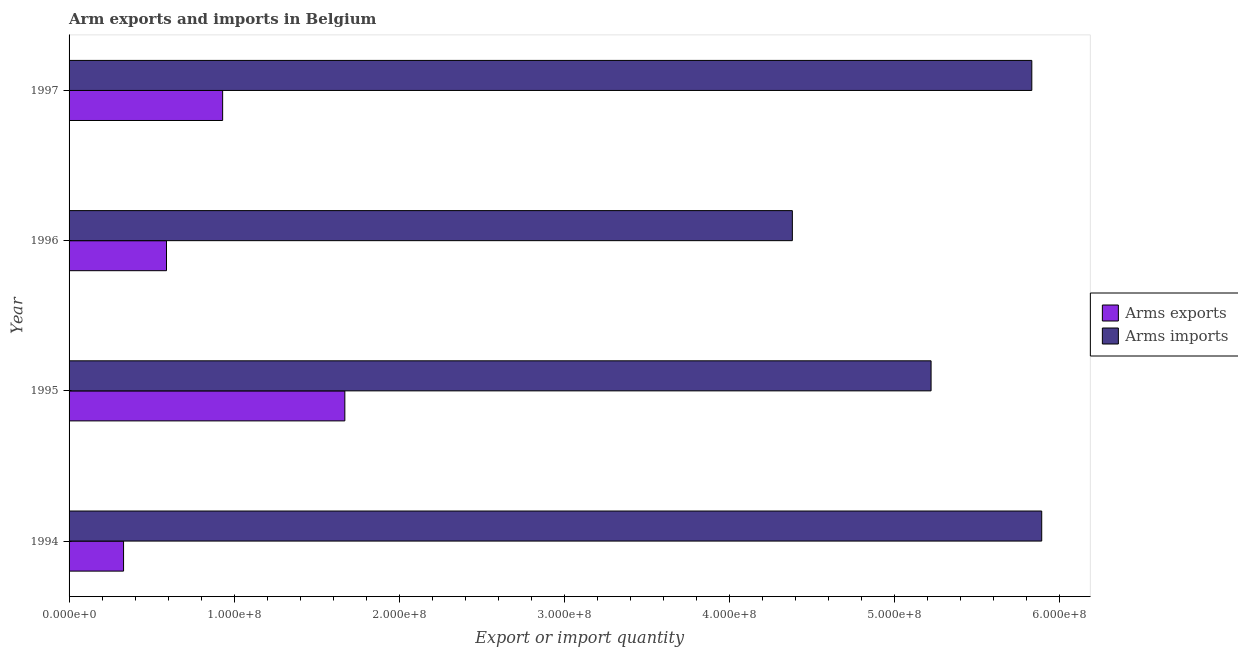How many different coloured bars are there?
Offer a very short reply. 2. How many bars are there on the 2nd tick from the top?
Make the answer very short. 2. How many bars are there on the 4th tick from the bottom?
Make the answer very short. 2. What is the arms imports in 1995?
Offer a terse response. 5.22e+08. Across all years, what is the maximum arms exports?
Offer a terse response. 1.67e+08. Across all years, what is the minimum arms exports?
Offer a very short reply. 3.30e+07. In which year was the arms imports maximum?
Give a very brief answer. 1994. What is the total arms imports in the graph?
Your response must be concise. 2.13e+09. What is the difference between the arms exports in 1996 and that in 1997?
Offer a very short reply. -3.40e+07. What is the difference between the arms imports in 1994 and the arms exports in 1996?
Give a very brief answer. 5.30e+08. What is the average arms imports per year?
Give a very brief answer. 5.33e+08. In the year 1996, what is the difference between the arms exports and arms imports?
Your answer should be very brief. -3.79e+08. In how many years, is the arms exports greater than 400000000 ?
Your response must be concise. 0. What is the ratio of the arms imports in 1995 to that in 1997?
Keep it short and to the point. 0.9. Is the arms exports in 1996 less than that in 1997?
Make the answer very short. Yes. What is the difference between the highest and the second highest arms exports?
Keep it short and to the point. 7.40e+07. What is the difference between the highest and the lowest arms exports?
Provide a short and direct response. 1.34e+08. Is the sum of the arms exports in 1994 and 1997 greater than the maximum arms imports across all years?
Offer a very short reply. No. What does the 1st bar from the top in 1996 represents?
Provide a succinct answer. Arms imports. What does the 2nd bar from the bottom in 1997 represents?
Keep it short and to the point. Arms imports. How many bars are there?
Ensure brevity in your answer.  8. How many years are there in the graph?
Your response must be concise. 4. Are the values on the major ticks of X-axis written in scientific E-notation?
Your response must be concise. Yes. Does the graph contain any zero values?
Your answer should be very brief. No. How are the legend labels stacked?
Your answer should be very brief. Vertical. What is the title of the graph?
Your response must be concise. Arm exports and imports in Belgium. Does "Mobile cellular" appear as one of the legend labels in the graph?
Your answer should be very brief. No. What is the label or title of the X-axis?
Give a very brief answer. Export or import quantity. What is the label or title of the Y-axis?
Keep it short and to the point. Year. What is the Export or import quantity of Arms exports in 1994?
Provide a succinct answer. 3.30e+07. What is the Export or import quantity of Arms imports in 1994?
Provide a short and direct response. 5.89e+08. What is the Export or import quantity of Arms exports in 1995?
Ensure brevity in your answer.  1.67e+08. What is the Export or import quantity in Arms imports in 1995?
Provide a short and direct response. 5.22e+08. What is the Export or import quantity in Arms exports in 1996?
Your answer should be compact. 5.90e+07. What is the Export or import quantity in Arms imports in 1996?
Provide a short and direct response. 4.38e+08. What is the Export or import quantity in Arms exports in 1997?
Keep it short and to the point. 9.30e+07. What is the Export or import quantity of Arms imports in 1997?
Offer a very short reply. 5.83e+08. Across all years, what is the maximum Export or import quantity in Arms exports?
Make the answer very short. 1.67e+08. Across all years, what is the maximum Export or import quantity of Arms imports?
Make the answer very short. 5.89e+08. Across all years, what is the minimum Export or import quantity in Arms exports?
Offer a very short reply. 3.30e+07. Across all years, what is the minimum Export or import quantity in Arms imports?
Your answer should be very brief. 4.38e+08. What is the total Export or import quantity in Arms exports in the graph?
Your answer should be compact. 3.52e+08. What is the total Export or import quantity of Arms imports in the graph?
Offer a very short reply. 2.13e+09. What is the difference between the Export or import quantity in Arms exports in 1994 and that in 1995?
Keep it short and to the point. -1.34e+08. What is the difference between the Export or import quantity in Arms imports in 1994 and that in 1995?
Ensure brevity in your answer.  6.70e+07. What is the difference between the Export or import quantity in Arms exports in 1994 and that in 1996?
Your answer should be very brief. -2.60e+07. What is the difference between the Export or import quantity in Arms imports in 1994 and that in 1996?
Your answer should be very brief. 1.51e+08. What is the difference between the Export or import quantity of Arms exports in 1994 and that in 1997?
Provide a short and direct response. -6.00e+07. What is the difference between the Export or import quantity in Arms imports in 1994 and that in 1997?
Offer a very short reply. 6.00e+06. What is the difference between the Export or import quantity in Arms exports in 1995 and that in 1996?
Offer a terse response. 1.08e+08. What is the difference between the Export or import quantity in Arms imports in 1995 and that in 1996?
Your response must be concise. 8.40e+07. What is the difference between the Export or import quantity in Arms exports in 1995 and that in 1997?
Keep it short and to the point. 7.40e+07. What is the difference between the Export or import quantity of Arms imports in 1995 and that in 1997?
Your answer should be compact. -6.10e+07. What is the difference between the Export or import quantity of Arms exports in 1996 and that in 1997?
Your answer should be very brief. -3.40e+07. What is the difference between the Export or import quantity in Arms imports in 1996 and that in 1997?
Give a very brief answer. -1.45e+08. What is the difference between the Export or import quantity of Arms exports in 1994 and the Export or import quantity of Arms imports in 1995?
Ensure brevity in your answer.  -4.89e+08. What is the difference between the Export or import quantity of Arms exports in 1994 and the Export or import quantity of Arms imports in 1996?
Provide a succinct answer. -4.05e+08. What is the difference between the Export or import quantity of Arms exports in 1994 and the Export or import quantity of Arms imports in 1997?
Keep it short and to the point. -5.50e+08. What is the difference between the Export or import quantity in Arms exports in 1995 and the Export or import quantity in Arms imports in 1996?
Provide a short and direct response. -2.71e+08. What is the difference between the Export or import quantity of Arms exports in 1995 and the Export or import quantity of Arms imports in 1997?
Keep it short and to the point. -4.16e+08. What is the difference between the Export or import quantity of Arms exports in 1996 and the Export or import quantity of Arms imports in 1997?
Make the answer very short. -5.24e+08. What is the average Export or import quantity in Arms exports per year?
Your response must be concise. 8.80e+07. What is the average Export or import quantity of Arms imports per year?
Make the answer very short. 5.33e+08. In the year 1994, what is the difference between the Export or import quantity of Arms exports and Export or import quantity of Arms imports?
Your answer should be compact. -5.56e+08. In the year 1995, what is the difference between the Export or import quantity in Arms exports and Export or import quantity in Arms imports?
Provide a short and direct response. -3.55e+08. In the year 1996, what is the difference between the Export or import quantity of Arms exports and Export or import quantity of Arms imports?
Your answer should be compact. -3.79e+08. In the year 1997, what is the difference between the Export or import quantity in Arms exports and Export or import quantity in Arms imports?
Your answer should be compact. -4.90e+08. What is the ratio of the Export or import quantity in Arms exports in 1994 to that in 1995?
Your response must be concise. 0.2. What is the ratio of the Export or import quantity of Arms imports in 1994 to that in 1995?
Ensure brevity in your answer.  1.13. What is the ratio of the Export or import quantity of Arms exports in 1994 to that in 1996?
Ensure brevity in your answer.  0.56. What is the ratio of the Export or import quantity in Arms imports in 1994 to that in 1996?
Make the answer very short. 1.34. What is the ratio of the Export or import quantity of Arms exports in 1994 to that in 1997?
Offer a very short reply. 0.35. What is the ratio of the Export or import quantity of Arms imports in 1994 to that in 1997?
Give a very brief answer. 1.01. What is the ratio of the Export or import quantity in Arms exports in 1995 to that in 1996?
Your response must be concise. 2.83. What is the ratio of the Export or import quantity in Arms imports in 1995 to that in 1996?
Your response must be concise. 1.19. What is the ratio of the Export or import quantity of Arms exports in 1995 to that in 1997?
Your answer should be compact. 1.8. What is the ratio of the Export or import quantity of Arms imports in 1995 to that in 1997?
Your answer should be very brief. 0.9. What is the ratio of the Export or import quantity in Arms exports in 1996 to that in 1997?
Give a very brief answer. 0.63. What is the ratio of the Export or import quantity of Arms imports in 1996 to that in 1997?
Your response must be concise. 0.75. What is the difference between the highest and the second highest Export or import quantity in Arms exports?
Keep it short and to the point. 7.40e+07. What is the difference between the highest and the lowest Export or import quantity in Arms exports?
Your answer should be compact. 1.34e+08. What is the difference between the highest and the lowest Export or import quantity in Arms imports?
Provide a short and direct response. 1.51e+08. 